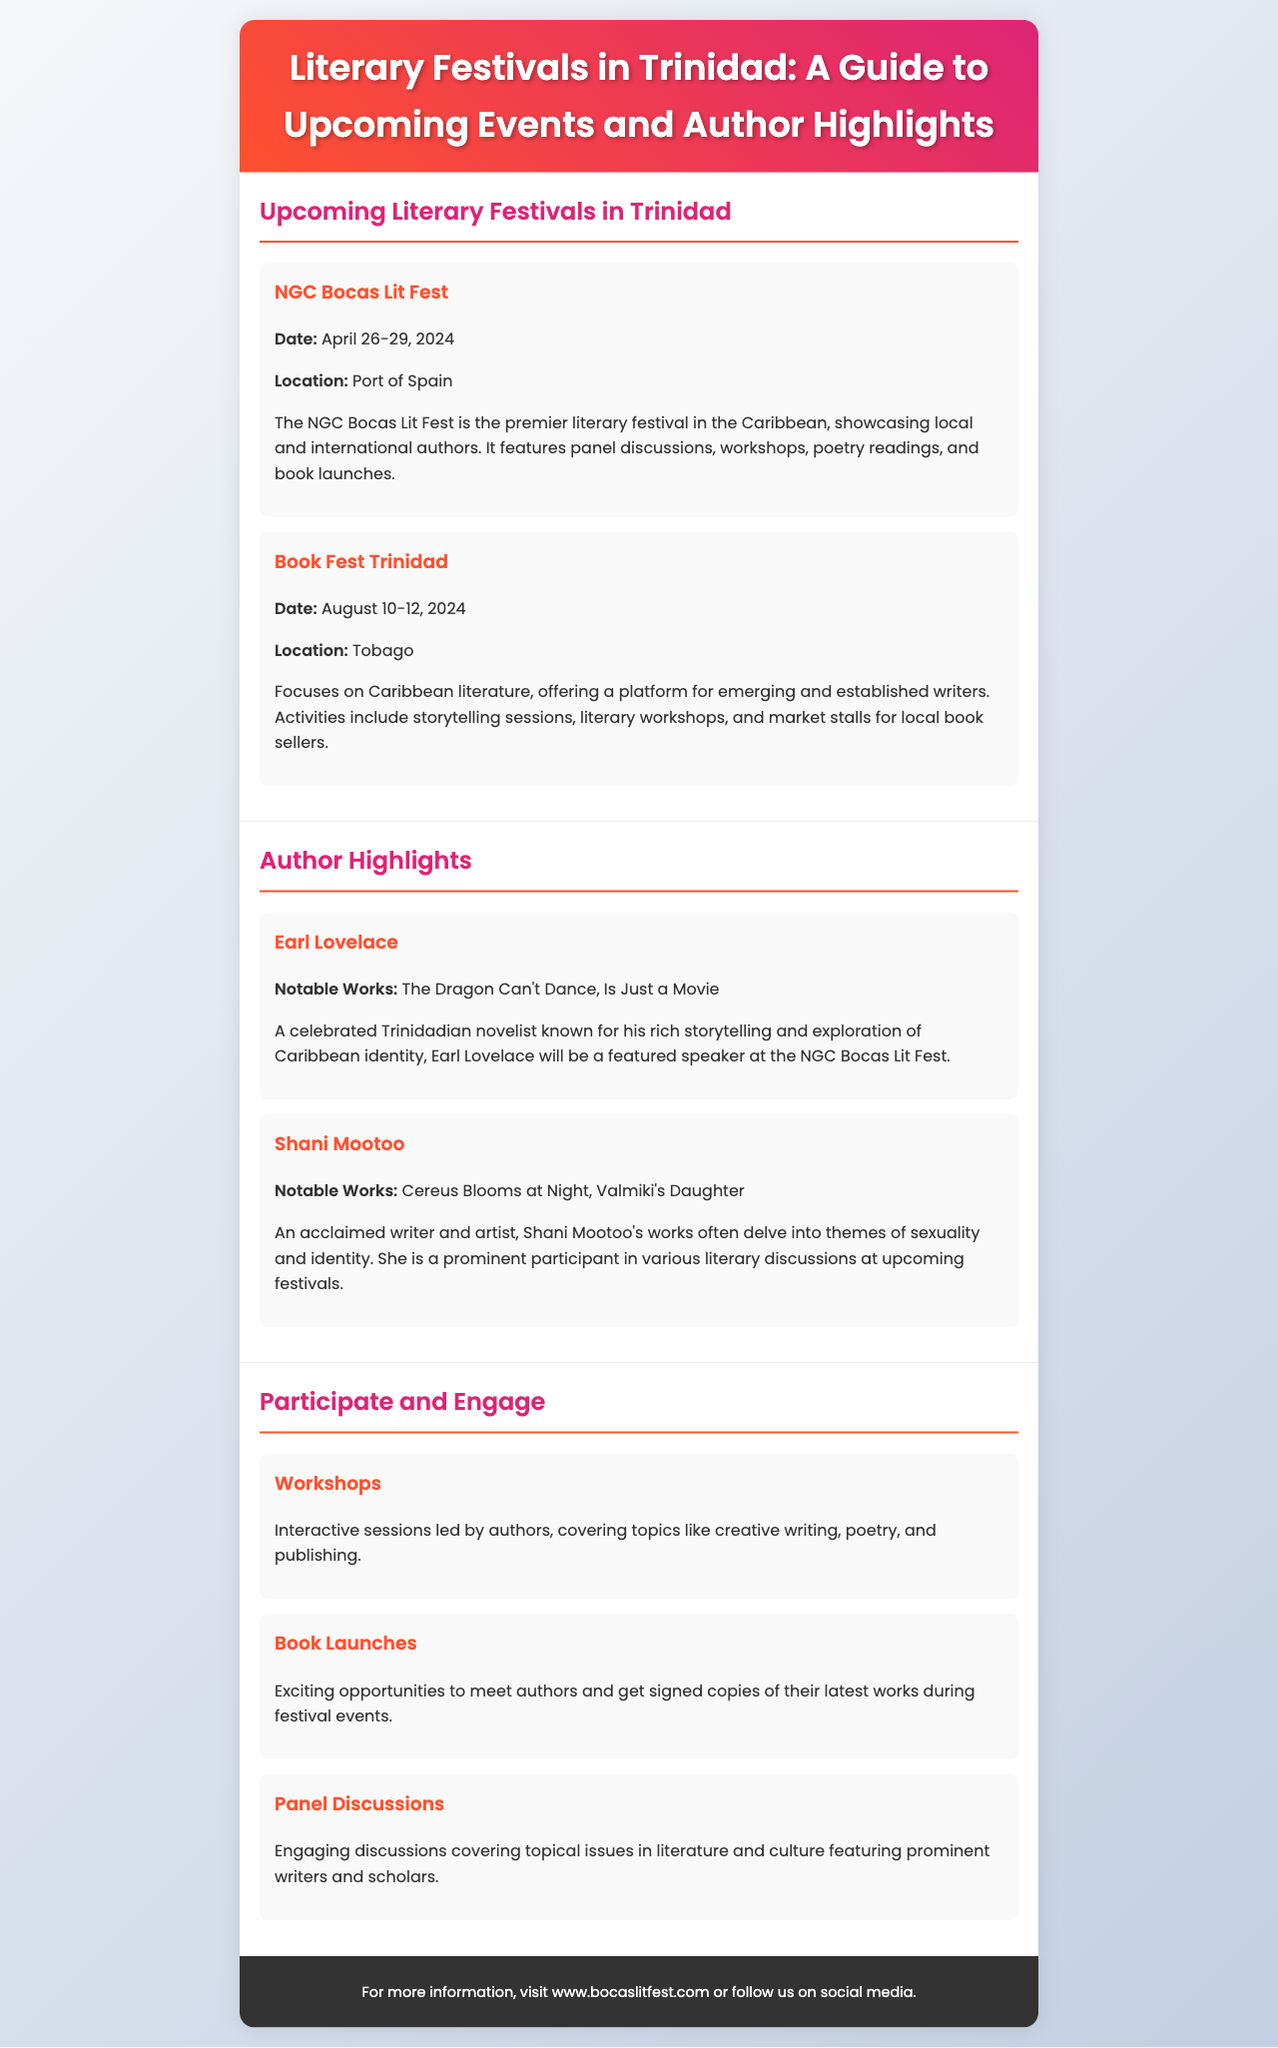What is the date of the NGC Bocas Lit Fest? The date can be found in the event section, indicating when the festival takes place.
Answer: April 26-29, 2024 Where is Book Fest Trinidad held? The location of Book Fest Trinidad is specified in the event details section of the document.
Answer: Tobago Who is a featured speaker at the NGC Bocas Lit Fest? The notable authors participating in the festival are listed, providing the names of featured speakers.
Answer: Earl Lovelace What types of activities are included in the literary festivals? The activities section outlines various options for participation and engagement at the festivals.
Answer: Workshops, Book Launches, Panel Discussions What are the notable works of Shani Mootoo? The notable works of the featured authors are mentioned in their profiles, providing insight into their literary contributions.
Answer: Cereus Blooms at Night, Valmiki's Daughter Which festival focuses on Caribbean literature? The document describes the main focus of each festival, which helps identify the one dedicated to Caribbean literature.
Answer: Book Fest Trinidad What is the theme of the discussions led by authors during workshops? The activities section describes the content covered in workshops, leading to an understanding of their themes.
Answer: Creative writing, poetry, and publishing How many days does the NGC Bocas Lit Fest last? The duration of the festival can be calculated based on the start and end date provided in the upcoming events section.
Answer: 4 days 